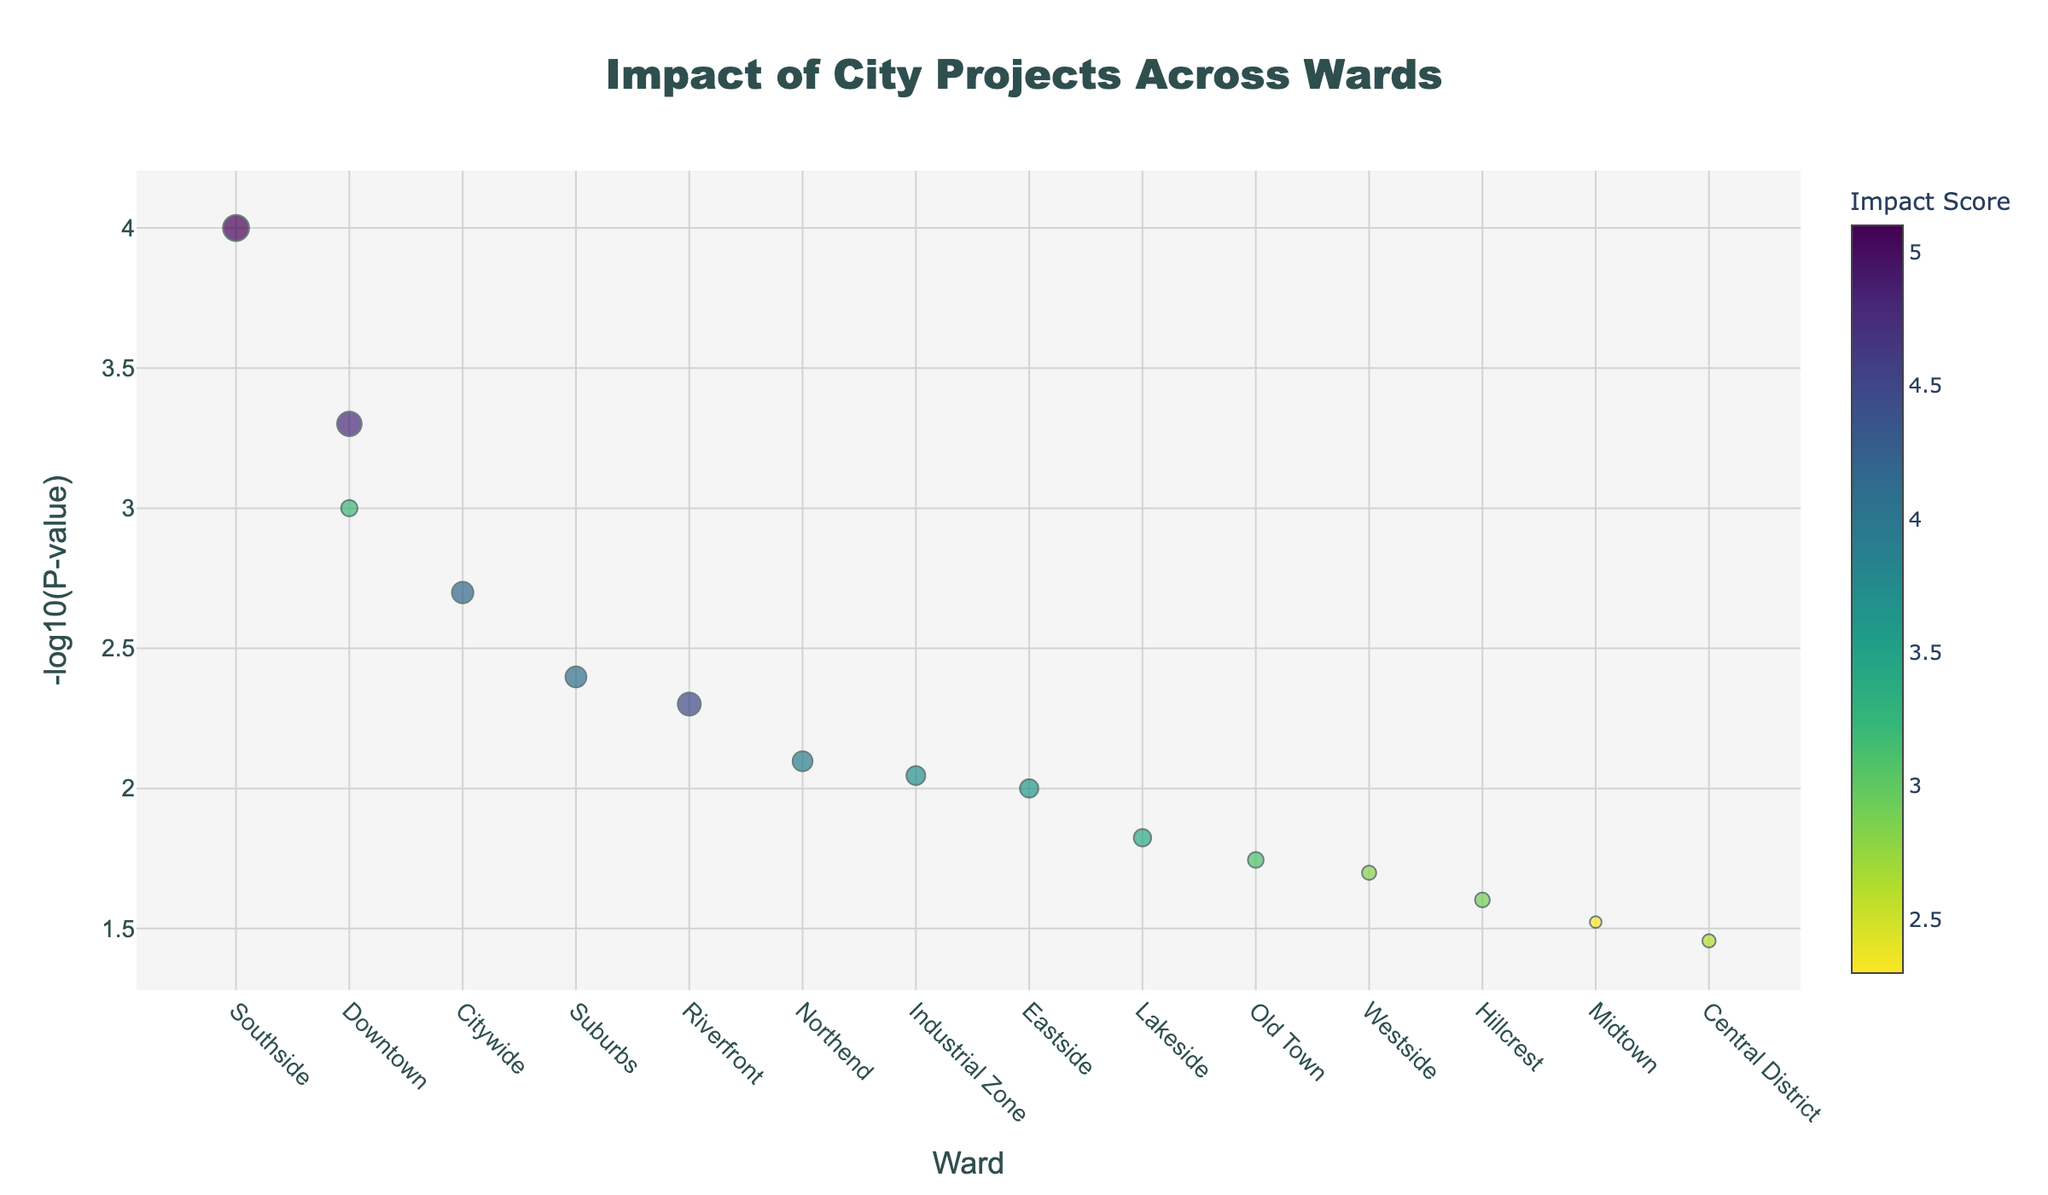what is the title of the plot? The title is usually located at the top of the plot. Here, it reads 'Impact of City Projects Across Wards'
Answer: Impact of City Projects Across Wards How is the size of the markers determined? The marker size is proportional to the 'ImpactScore' for each project. Larger ImpactScores lead to bigger marker sizes.
Answer: By ImpactScore which ward has the lowest p-value project? The y-axis represents -log10(p-value). The highest point on this axis indicates the lowest p-value. The highest point is above the 'Southside' ward, referring to the 'Affordable Housing' project.
Answer: Southside which projects have a greater impact score than 3.5? Reviewing the color scale and marker sizes, the projects with ImpactScores above 3.5 are 'Community Center,' 'Public Library Expansion,' 'Affordable Housing,' 'Green Energy Initiative,' 'Job Training Center,' 'Elementary School Renovation'
Answer: Community Center, Public Library Expansion, Affordable Housing, Green Energy Initiative, Job Training Center, Elementary School Renovation what is represented by the color of the markers? The color of the markers represents the ImpactScore. Higher ImpactScores are shown in one range of the color scale, likely somewhere in the darker or brighter portion depending on the scale.
Answer: ImpactScore which project in the downtown ward has a higher impact? Compare the marker sizes for projects in the Downtown ward. 'Public Transit Expansion' has a higher ImpactScore than 'Road Maintenance,' as indicated by its larger marker size.
Answer: Public Transit Expansion What is the relationship between p-value and -log10(p-value), and how is it reflected in the plot? A lower p-value corresponds to a higher -log10(p-value) and is reflected by markers higher up on the y-axis. This inverse relationship means significant projects (with low p-values) appear higher up.
Answer: Inverse; low p-value -> high -log10(p-value) Which ward has the highest average -log10(p-value)? To find this, assess the general height of markers in each ward. The Southside contains the marker representing 'Affordable Housing' which has the highest -log10(p-value). This suggests it could have the highest average value, especially if other markers are high too.
Answer: Southside 